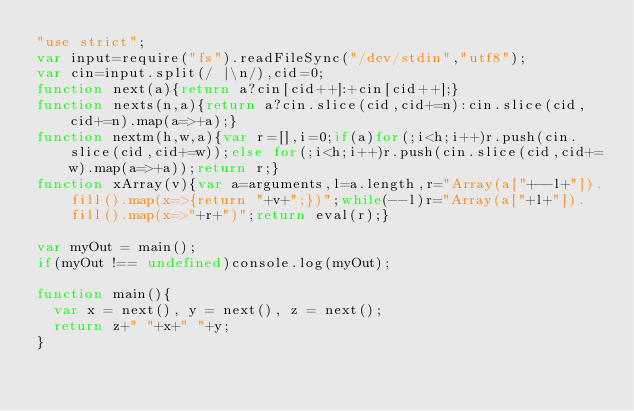Convert code to text. <code><loc_0><loc_0><loc_500><loc_500><_JavaScript_>"use strict";
var input=require("fs").readFileSync("/dev/stdin","utf8");
var cin=input.split(/ |\n/),cid=0;
function next(a){return a?cin[cid++]:+cin[cid++];}
function nexts(n,a){return a?cin.slice(cid,cid+=n):cin.slice(cid,cid+=n).map(a=>+a);}
function nextm(h,w,a){var r=[],i=0;if(a)for(;i<h;i++)r.push(cin.slice(cid,cid+=w));else for(;i<h;i++)r.push(cin.slice(cid,cid+=w).map(a=>+a));return r;}
function xArray(v){var a=arguments,l=a.length,r="Array(a["+--l+"]).fill().map(x=>{return "+v+";})";while(--l)r="Array(a["+l+"]).fill().map(x=>"+r+")";return eval(r);}

var myOut = main();
if(myOut !== undefined)console.log(myOut);

function main(){
  var x = next(), y = next(), z = next();
  return z+" "+x+" "+y;
}</code> 